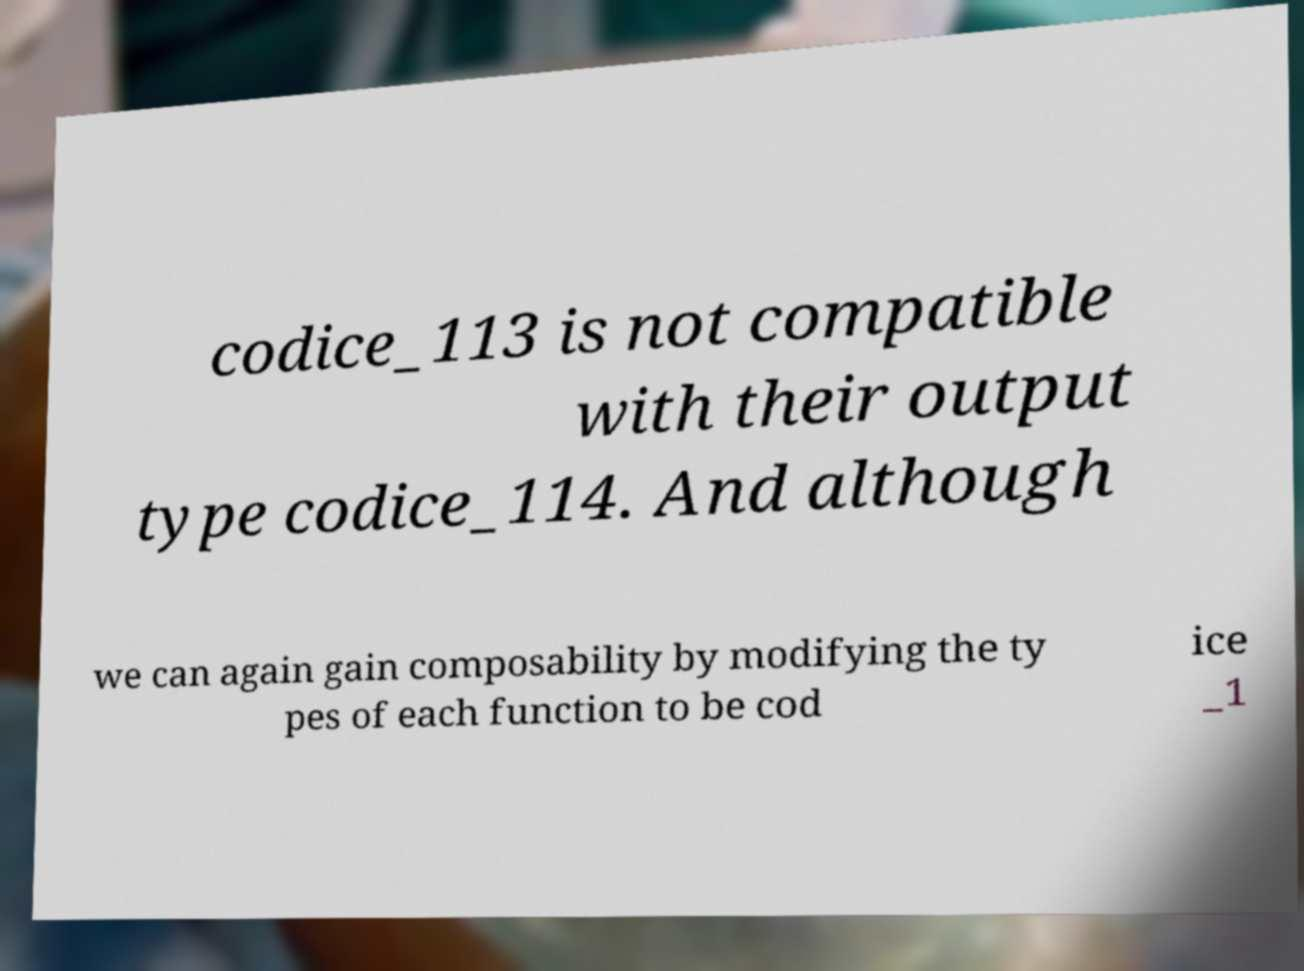Please identify and transcribe the text found in this image. codice_113 is not compatible with their output type codice_114. And although we can again gain composability by modifying the ty pes of each function to be cod ice _1 